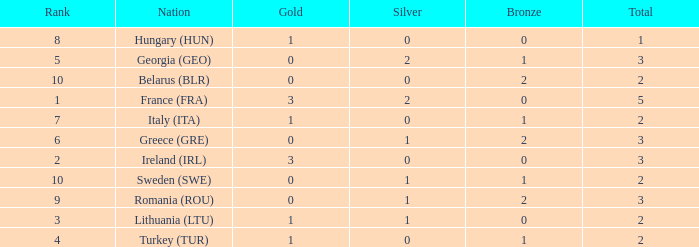Write the full table. {'header': ['Rank', 'Nation', 'Gold', 'Silver', 'Bronze', 'Total'], 'rows': [['8', 'Hungary (HUN)', '1', '0', '0', '1'], ['5', 'Georgia (GEO)', '0', '2', '1', '3'], ['10', 'Belarus (BLR)', '0', '0', '2', '2'], ['1', 'France (FRA)', '3', '2', '0', '5'], ['7', 'Italy (ITA)', '1', '0', '1', '2'], ['6', 'Greece (GRE)', '0', '1', '2', '3'], ['2', 'Ireland (IRL)', '3', '0', '0', '3'], ['10', 'Sweden (SWE)', '0', '1', '1', '2'], ['9', 'Romania (ROU)', '0', '1', '2', '3'], ['3', 'Lithuania (LTU)', '1', '1', '0', '2'], ['4', 'Turkey (TUR)', '1', '0', '1', '2']]} What's the total when the gold is less than 0 and silver is less than 1? None. 